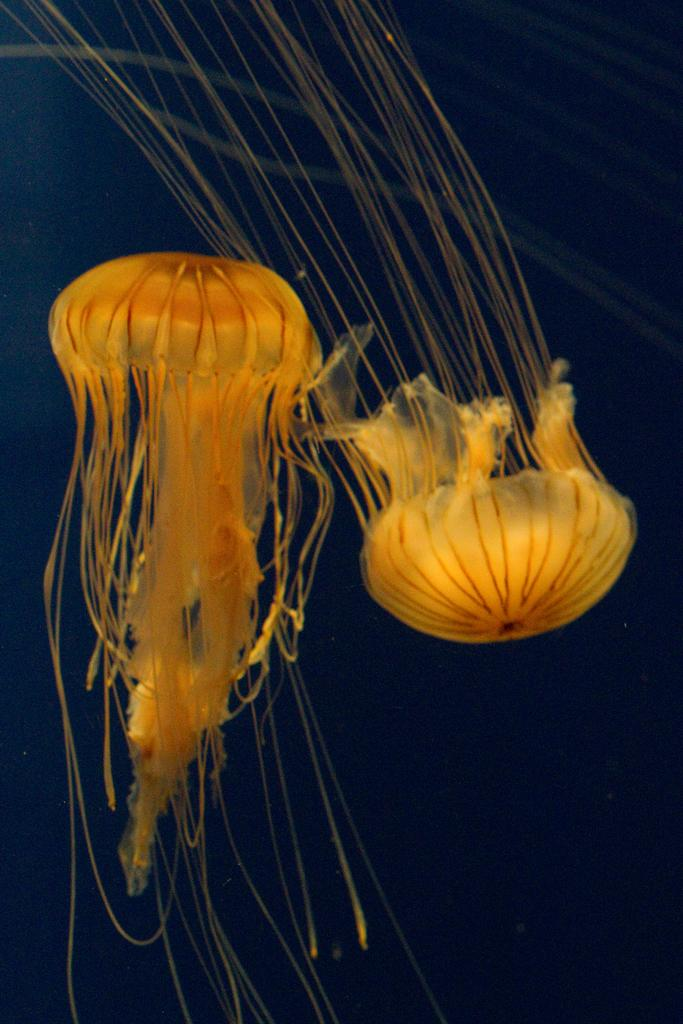What type of sea creatures are in the image? There are two yellow color jellyfish in the image. What can be observed about the background of the image? The background of the image is dark. How long does the bear take to turn off the faucet in the image? There is no bear or faucet present in the image; it features two yellow jellyfish against a dark background. 